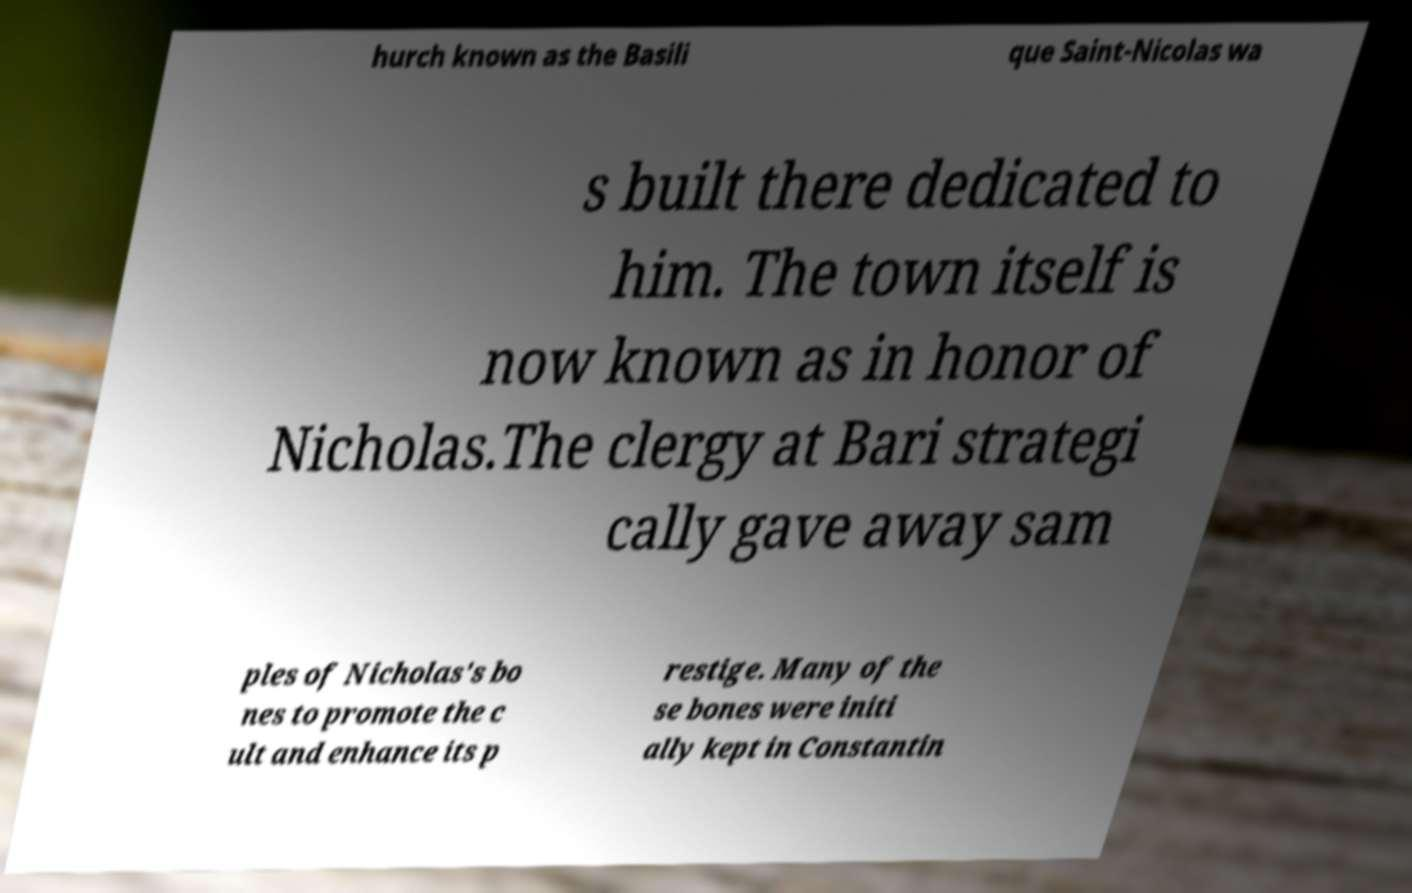I need the written content from this picture converted into text. Can you do that? hurch known as the Basili que Saint-Nicolas wa s built there dedicated to him. The town itself is now known as in honor of Nicholas.The clergy at Bari strategi cally gave away sam ples of Nicholas's bo nes to promote the c ult and enhance its p restige. Many of the se bones were initi ally kept in Constantin 